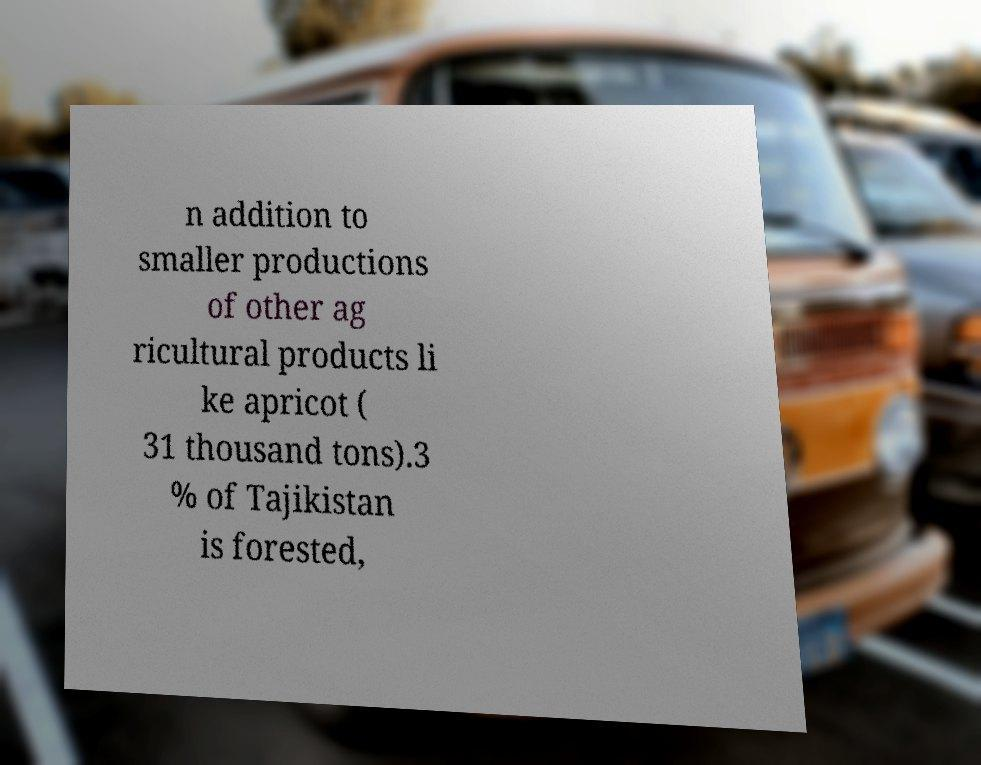Can you read and provide the text displayed in the image?This photo seems to have some interesting text. Can you extract and type it out for me? n addition to smaller productions of other ag ricultural products li ke apricot ( 31 thousand tons).3 % of Tajikistan is forested, 